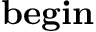Convert formula to latex. <formula><loc_0><loc_0><loc_500><loc_500>b e g i n</formula> 